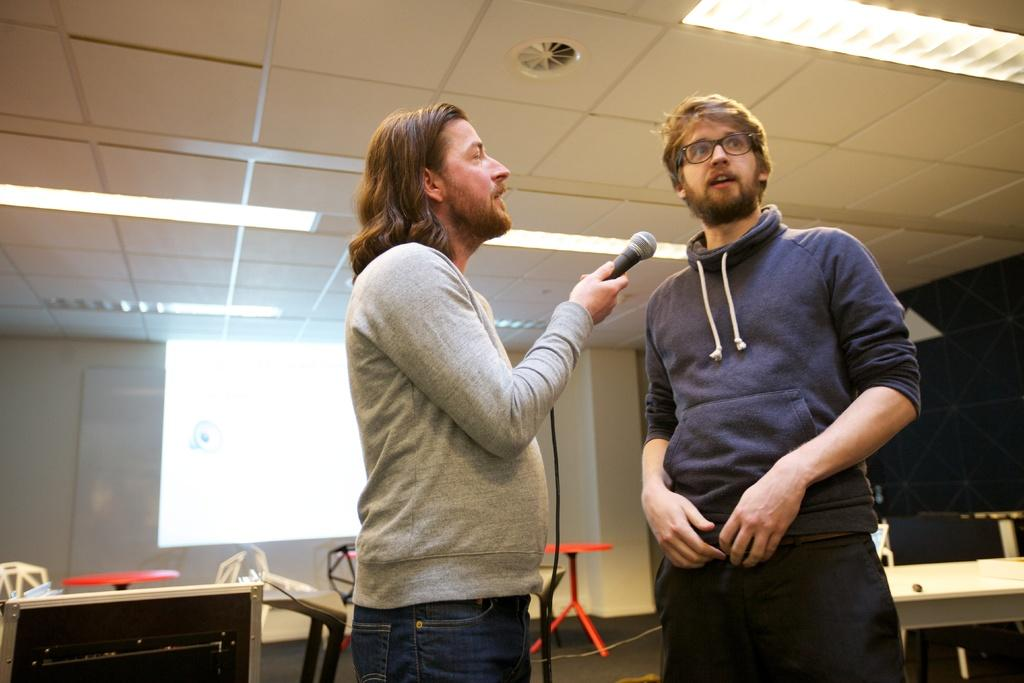What are the persons in the image doing? The persons in the image are standing and holding microphones. What can be seen in the background of the image? There is a table, chairs, a screen, a board, and a wall in the background of the image. What type of arch can be seen in the image? There is no arch present in the image. What day of the week is depicted in the image? The image does not depict a specific day of the week. 